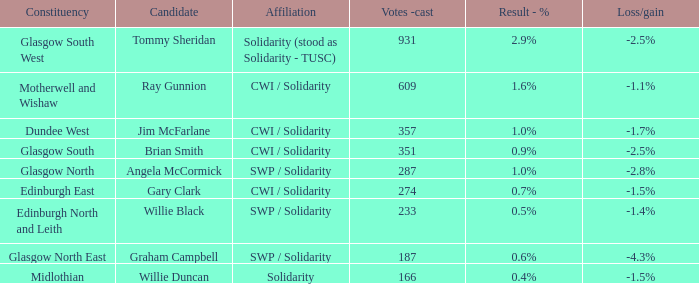When 166 votes were cast, what was the resulting gain or loss? -1.5%. 